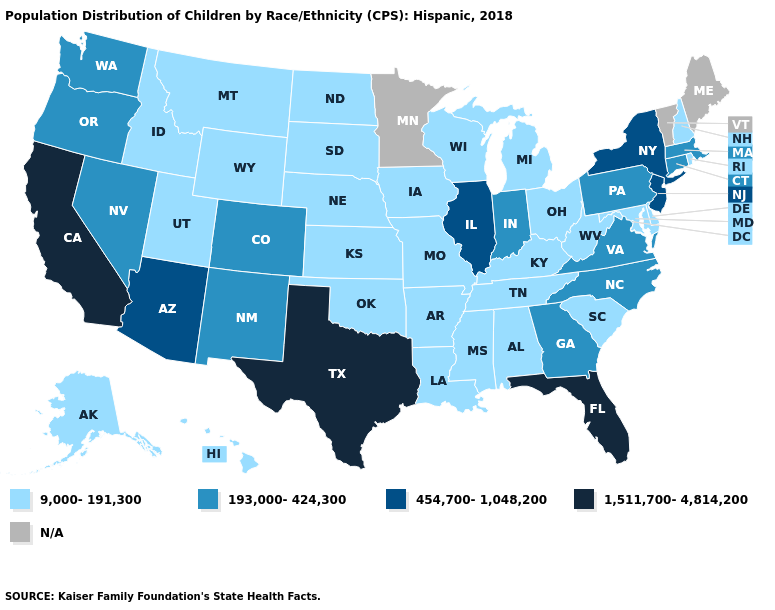Name the states that have a value in the range N/A?
Be succinct. Maine, Minnesota, Vermont. Does the first symbol in the legend represent the smallest category?
Be succinct. Yes. What is the value of Iowa?
Write a very short answer. 9,000-191,300. What is the highest value in the West ?
Short answer required. 1,511,700-4,814,200. What is the lowest value in states that border Michigan?
Be succinct. 9,000-191,300. Name the states that have a value in the range 193,000-424,300?
Answer briefly. Colorado, Connecticut, Georgia, Indiana, Massachusetts, Nevada, New Mexico, North Carolina, Oregon, Pennsylvania, Virginia, Washington. Name the states that have a value in the range 193,000-424,300?
Quick response, please. Colorado, Connecticut, Georgia, Indiana, Massachusetts, Nevada, New Mexico, North Carolina, Oregon, Pennsylvania, Virginia, Washington. What is the value of New Hampshire?
Be succinct. 9,000-191,300. How many symbols are there in the legend?
Short answer required. 5. What is the value of Maryland?
Write a very short answer. 9,000-191,300. What is the highest value in the South ?
Short answer required. 1,511,700-4,814,200. What is the value of Arizona?
Keep it brief. 454,700-1,048,200. What is the value of Idaho?
Short answer required. 9,000-191,300. Does Massachusetts have the lowest value in the USA?
Concise answer only. No. 